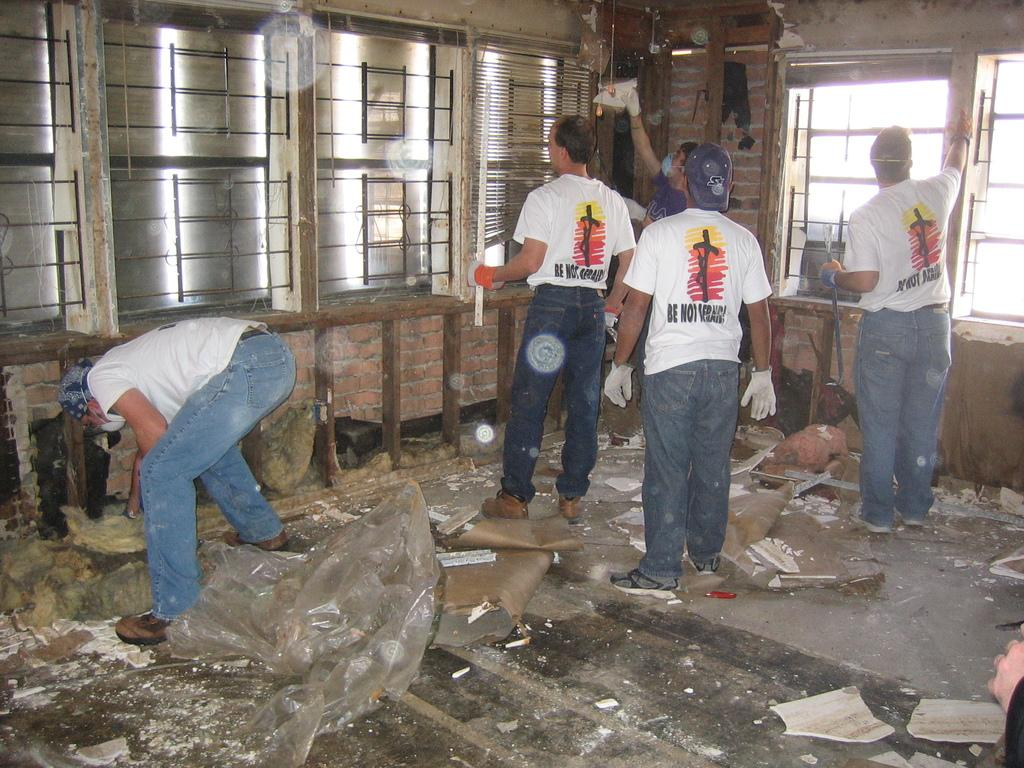How many people are in the image? There are five persons standing in the image. What are the persons holding in the image? The persons are holding objects. What can be seen in the background of the image? There are windows in the image. What type of objects are present in the image? There are covers and other objects present in the image. What type of land can be seen in the image? There is no land visible in the image; it features five persons holding objects and windows in the background. How do the nerves of the persons in the image appear? There is no information about the nerves of the persons in the image, as it focuses on their actions and the objects they are holding. 